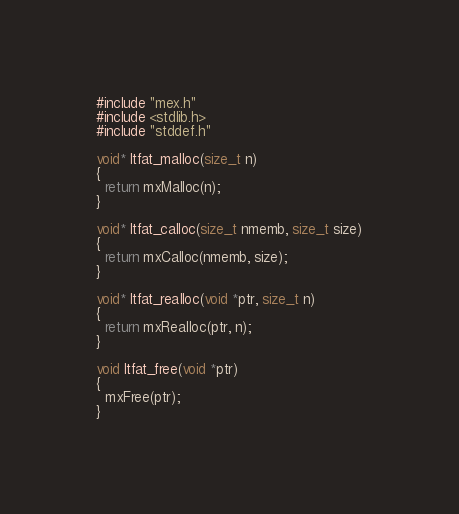Convert code to text. <code><loc_0><loc_0><loc_500><loc_500><_C_>#include "mex.h"
#include <stdlib.h>
#include "stddef.h"

void* ltfat_malloc(size_t n)
{
  return mxMalloc(n);
}

void* ltfat_calloc(size_t nmemb, size_t size)
{
  return mxCalloc(nmemb, size);
}

void* ltfat_realloc(void *ptr, size_t n)
{
  return mxRealloc(ptr, n);
}

void ltfat_free(void *ptr)
{
  mxFree(ptr);
}
</code> 